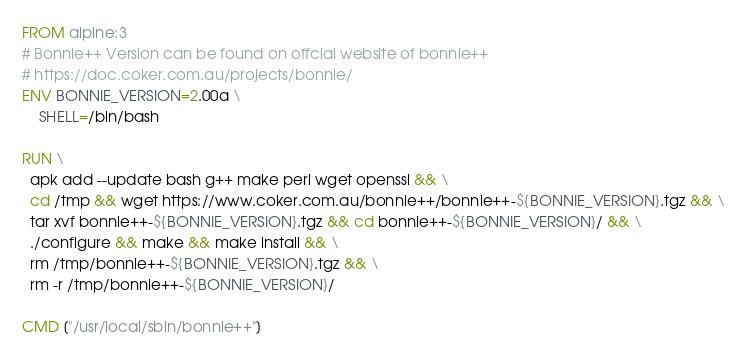<code> <loc_0><loc_0><loc_500><loc_500><_Dockerfile_>FROM alpine:3
# Bonnie++ Version can be found on offcial website of bonnie++
# https://doc.coker.com.au/projects/bonnie/
ENV BONNIE_VERSION=2.00a \
    SHELL=/bin/bash

RUN \
  apk add --update bash g++ make perl wget openssl && \
  cd /tmp && wget https://www.coker.com.au/bonnie++/bonnie++-${BONNIE_VERSION}.tgz && \
  tar xvf bonnie++-${BONNIE_VERSION}.tgz && cd bonnie++-${BONNIE_VERSION}/ && \
  ./configure && make && make install && \
  rm /tmp/bonnie++-${BONNIE_VERSION}.tgz && \
  rm -r /tmp/bonnie++-${BONNIE_VERSION}/

CMD ["/usr/local/sbin/bonnie++"]
</code> 